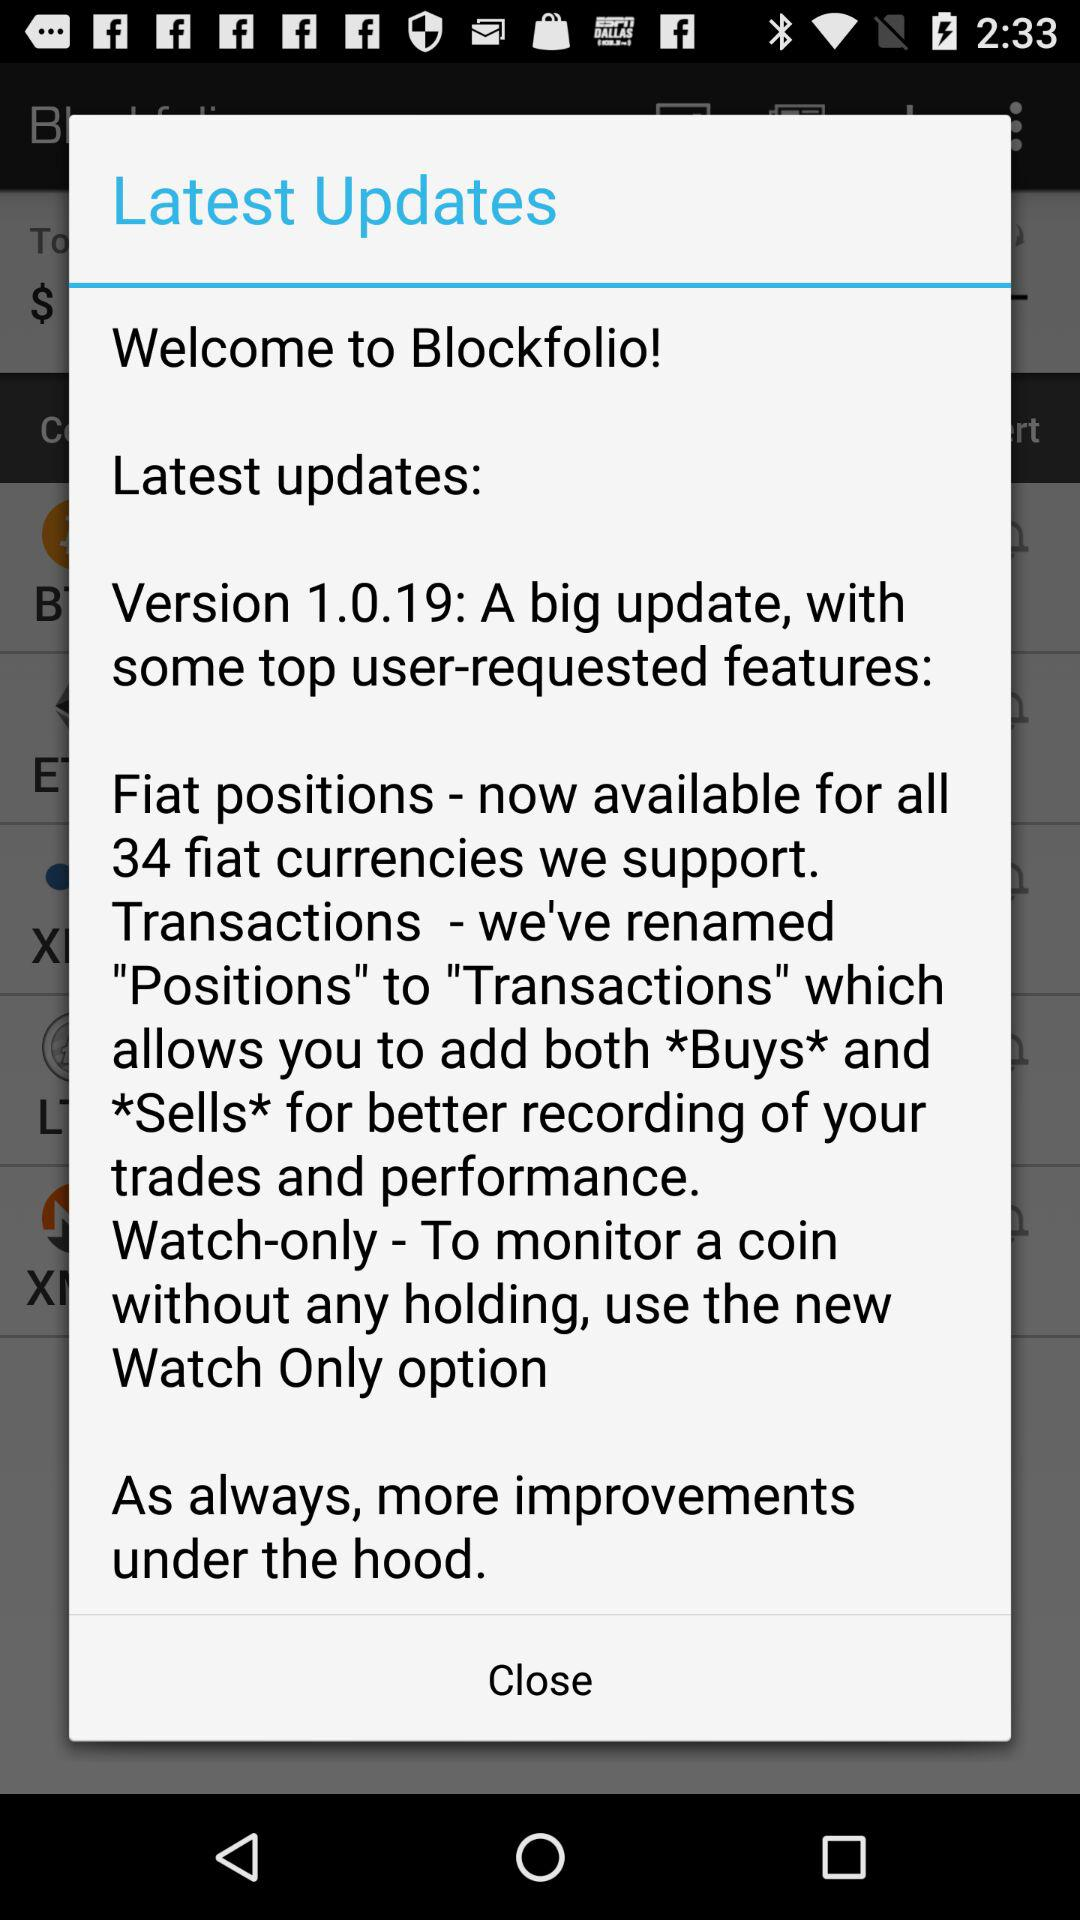Which is the latest version? The latest version is 1.0.19. 